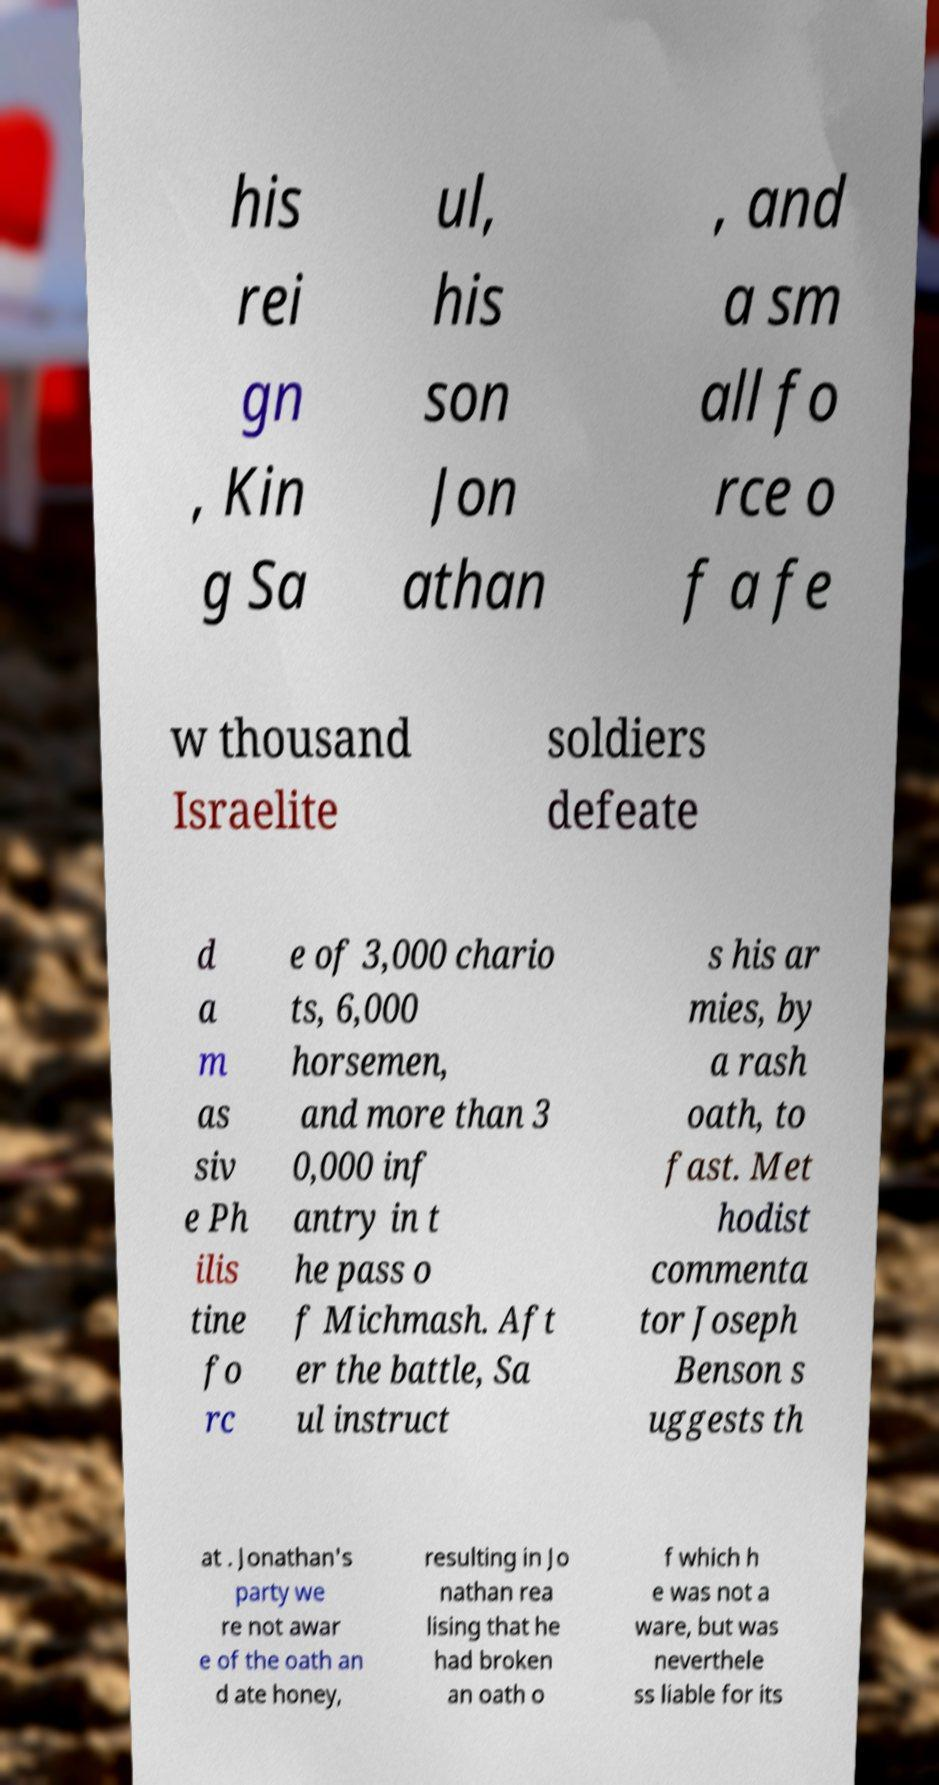Could you assist in decoding the text presented in this image and type it out clearly? his rei gn , Kin g Sa ul, his son Jon athan , and a sm all fo rce o f a fe w thousand Israelite soldiers defeate d a m as siv e Ph ilis tine fo rc e of 3,000 chario ts, 6,000 horsemen, and more than 3 0,000 inf antry in t he pass o f Michmash. Aft er the battle, Sa ul instruct s his ar mies, by a rash oath, to fast. Met hodist commenta tor Joseph Benson s uggests th at . Jonathan's party we re not awar e of the oath an d ate honey, resulting in Jo nathan rea lising that he had broken an oath o f which h e was not a ware, but was neverthele ss liable for its 